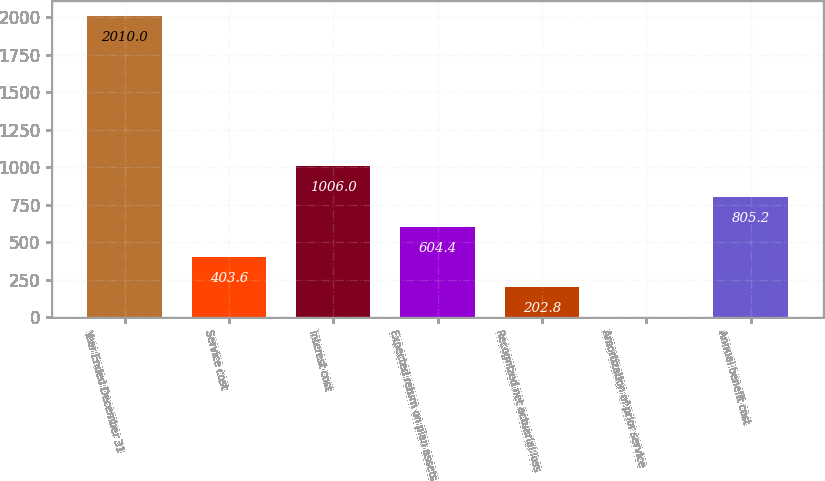<chart> <loc_0><loc_0><loc_500><loc_500><bar_chart><fcel>Year Ended December 31<fcel>Service cost<fcel>Interest cost<fcel>Expected return on plan assets<fcel>Recognized net actuarial loss<fcel>Amortization of prior service<fcel>Annual benefit cost<nl><fcel>2010<fcel>403.6<fcel>1006<fcel>604.4<fcel>202.8<fcel>2<fcel>805.2<nl></chart> 